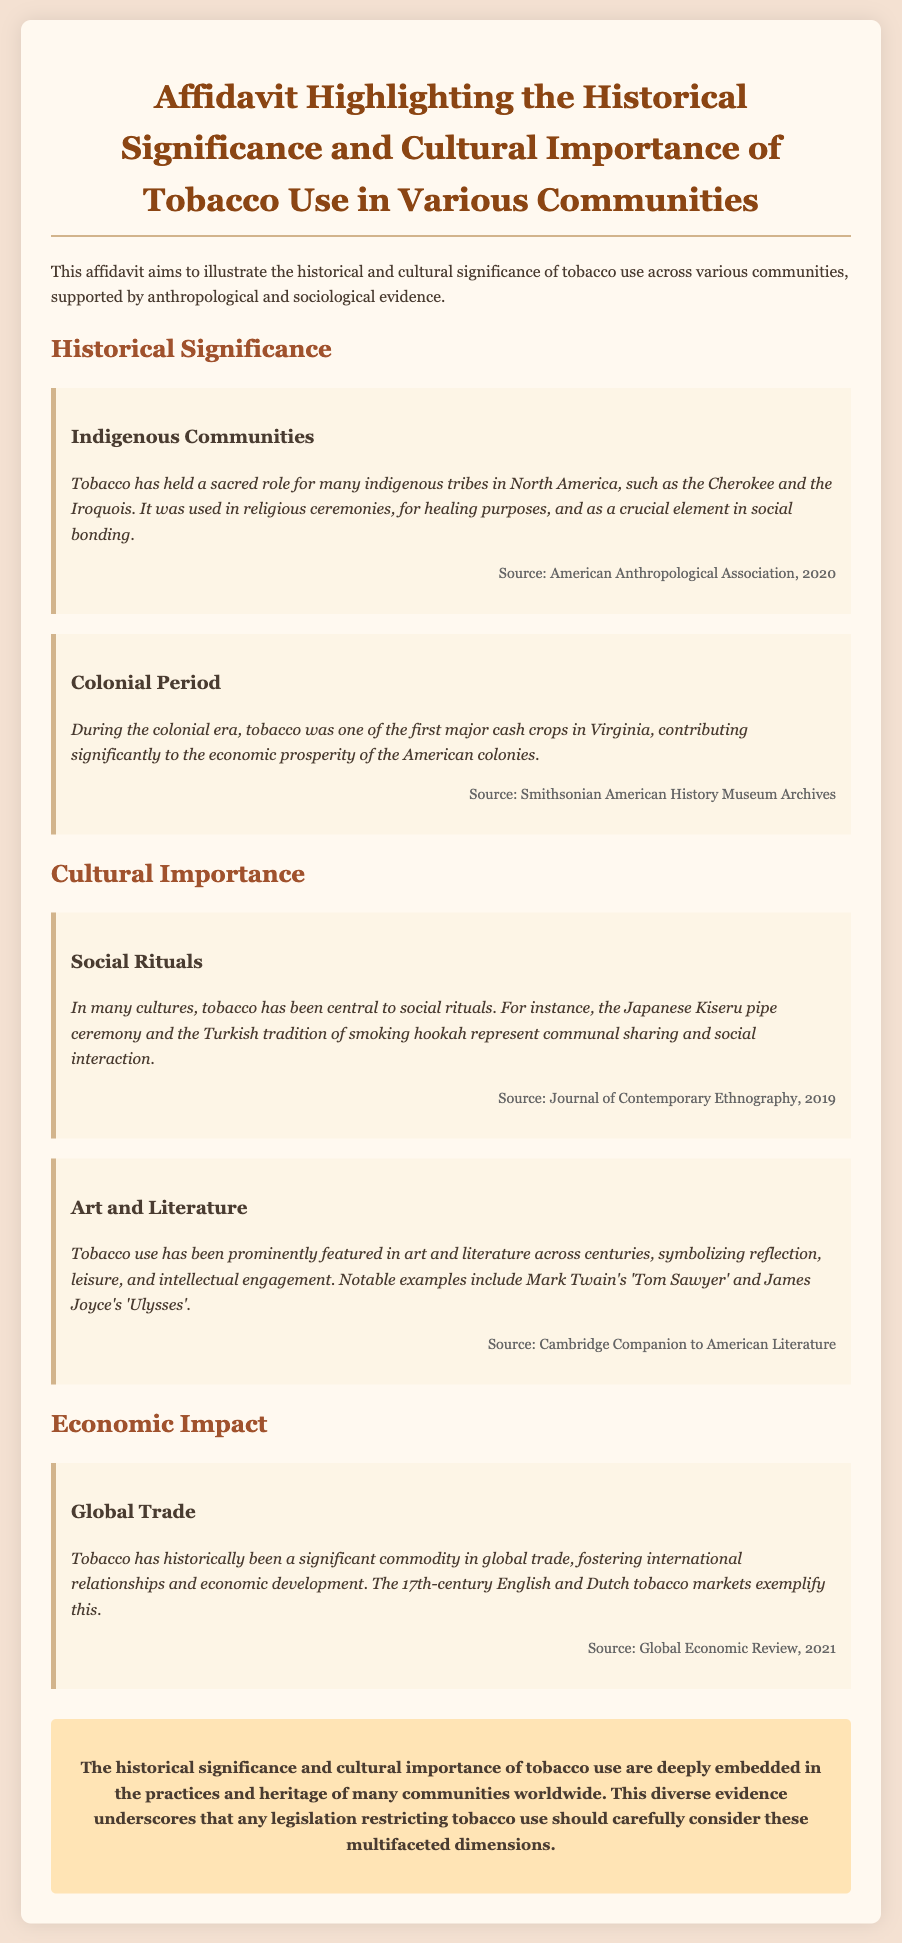what is the affidavit highlighting? The affidavit highlights the historical significance and cultural importance of tobacco use across various communities.
Answer: historical significance and cultural importance of tobacco use which indigenous tribes are mentioned? The document mentions the Cherokee and the Iroquois tribes in relation to sacred tobacco use.
Answer: Cherokee and the Iroquois what economic role did tobacco play during the colonial period? Tobacco was one of the first major cash crops in Virginia, contributing significantly to economic prosperity.
Answer: major cash crop what social ritual is associated with tobacco in Japan? The document references the Japanese Kiseru pipe ceremony as a social ritual involving tobacco.
Answer: Kiseru pipe ceremony who is an author mentioned in relation to tobacco in literature? Mark Twain is mentioned in relation to tobacco use in the context of literature, specifically in 'Tom Sawyer'.
Answer: Mark Twain what year did the Global Economic Review publish its findings on tobacco? The Global Economic Review published findings on tobacco in the year 2021.
Answer: 2021 what does the document say tobacco symbolizes in art and literature? Tobacco is said to symbolize reflection, leisure, and intellectual engagement in art and literature.
Answer: reflection, leisure, intellectual engagement what is the conclusion of the affidavit? The conclusion states that the significance and importance of tobacco use should be considered in legislation.
Answer: consideration in legislation 